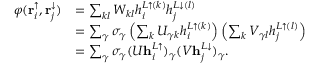Convert formula to latex. <formula><loc_0><loc_0><loc_500><loc_500>\begin{array} { r l } { \varphi ( r _ { i } ^ { \uparrow } , r _ { j } ^ { \downarrow } ) } & { = \sum _ { k l } W _ { k l } h _ { i } ^ { L \uparrow ( k ) } h _ { j } ^ { L \downarrow ( l ) } } \\ & { = \sum _ { \gamma } \sigma _ { \gamma } \left ( \sum _ { k } U _ { \gamma k } h _ { i } ^ { L \uparrow ( k ) } \right ) \left ( \sum _ { k } V _ { \gamma l } h _ { j } ^ { L \uparrow ( l ) } \right ) } \\ & { = \sum _ { \gamma } \sigma _ { \gamma } ( U h _ { i } ^ { L \uparrow } ) _ { \gamma } ( V h _ { j } ^ { L \downarrow } ) _ { \gamma } . } \end{array}</formula> 